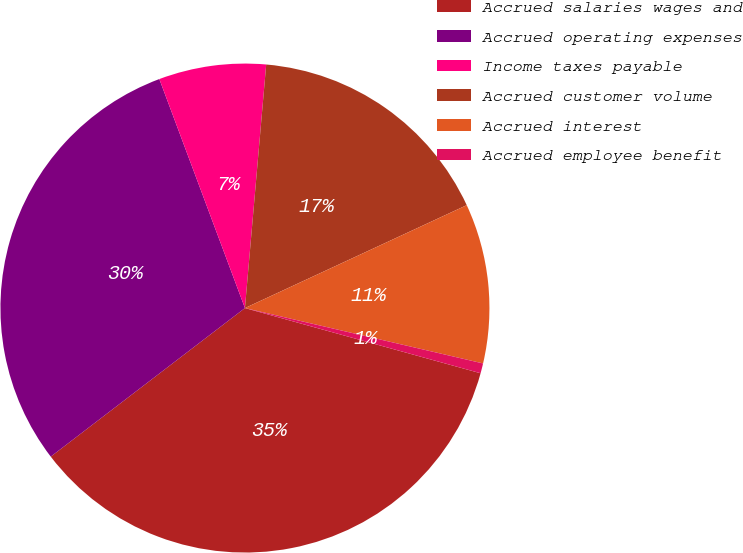Convert chart to OTSL. <chart><loc_0><loc_0><loc_500><loc_500><pie_chart><fcel>Accrued salaries wages and<fcel>Accrued operating expenses<fcel>Income taxes payable<fcel>Accrued customer volume<fcel>Accrued interest<fcel>Accrued employee benefit<nl><fcel>35.31%<fcel>29.7%<fcel>7.08%<fcel>16.7%<fcel>10.55%<fcel>0.66%<nl></chart> 